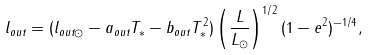Convert formula to latex. <formula><loc_0><loc_0><loc_500><loc_500>l _ { o u t } = ( l _ { o u t \odot } - a _ { o u t } T _ { * } - b _ { o u t } T _ { * } ^ { 2 } ) \left ( \frac { L } { L _ { \odot } } \right ) ^ { 1 / 2 } ( 1 - e ^ { 2 } ) ^ { - 1 / 4 } ,</formula> 